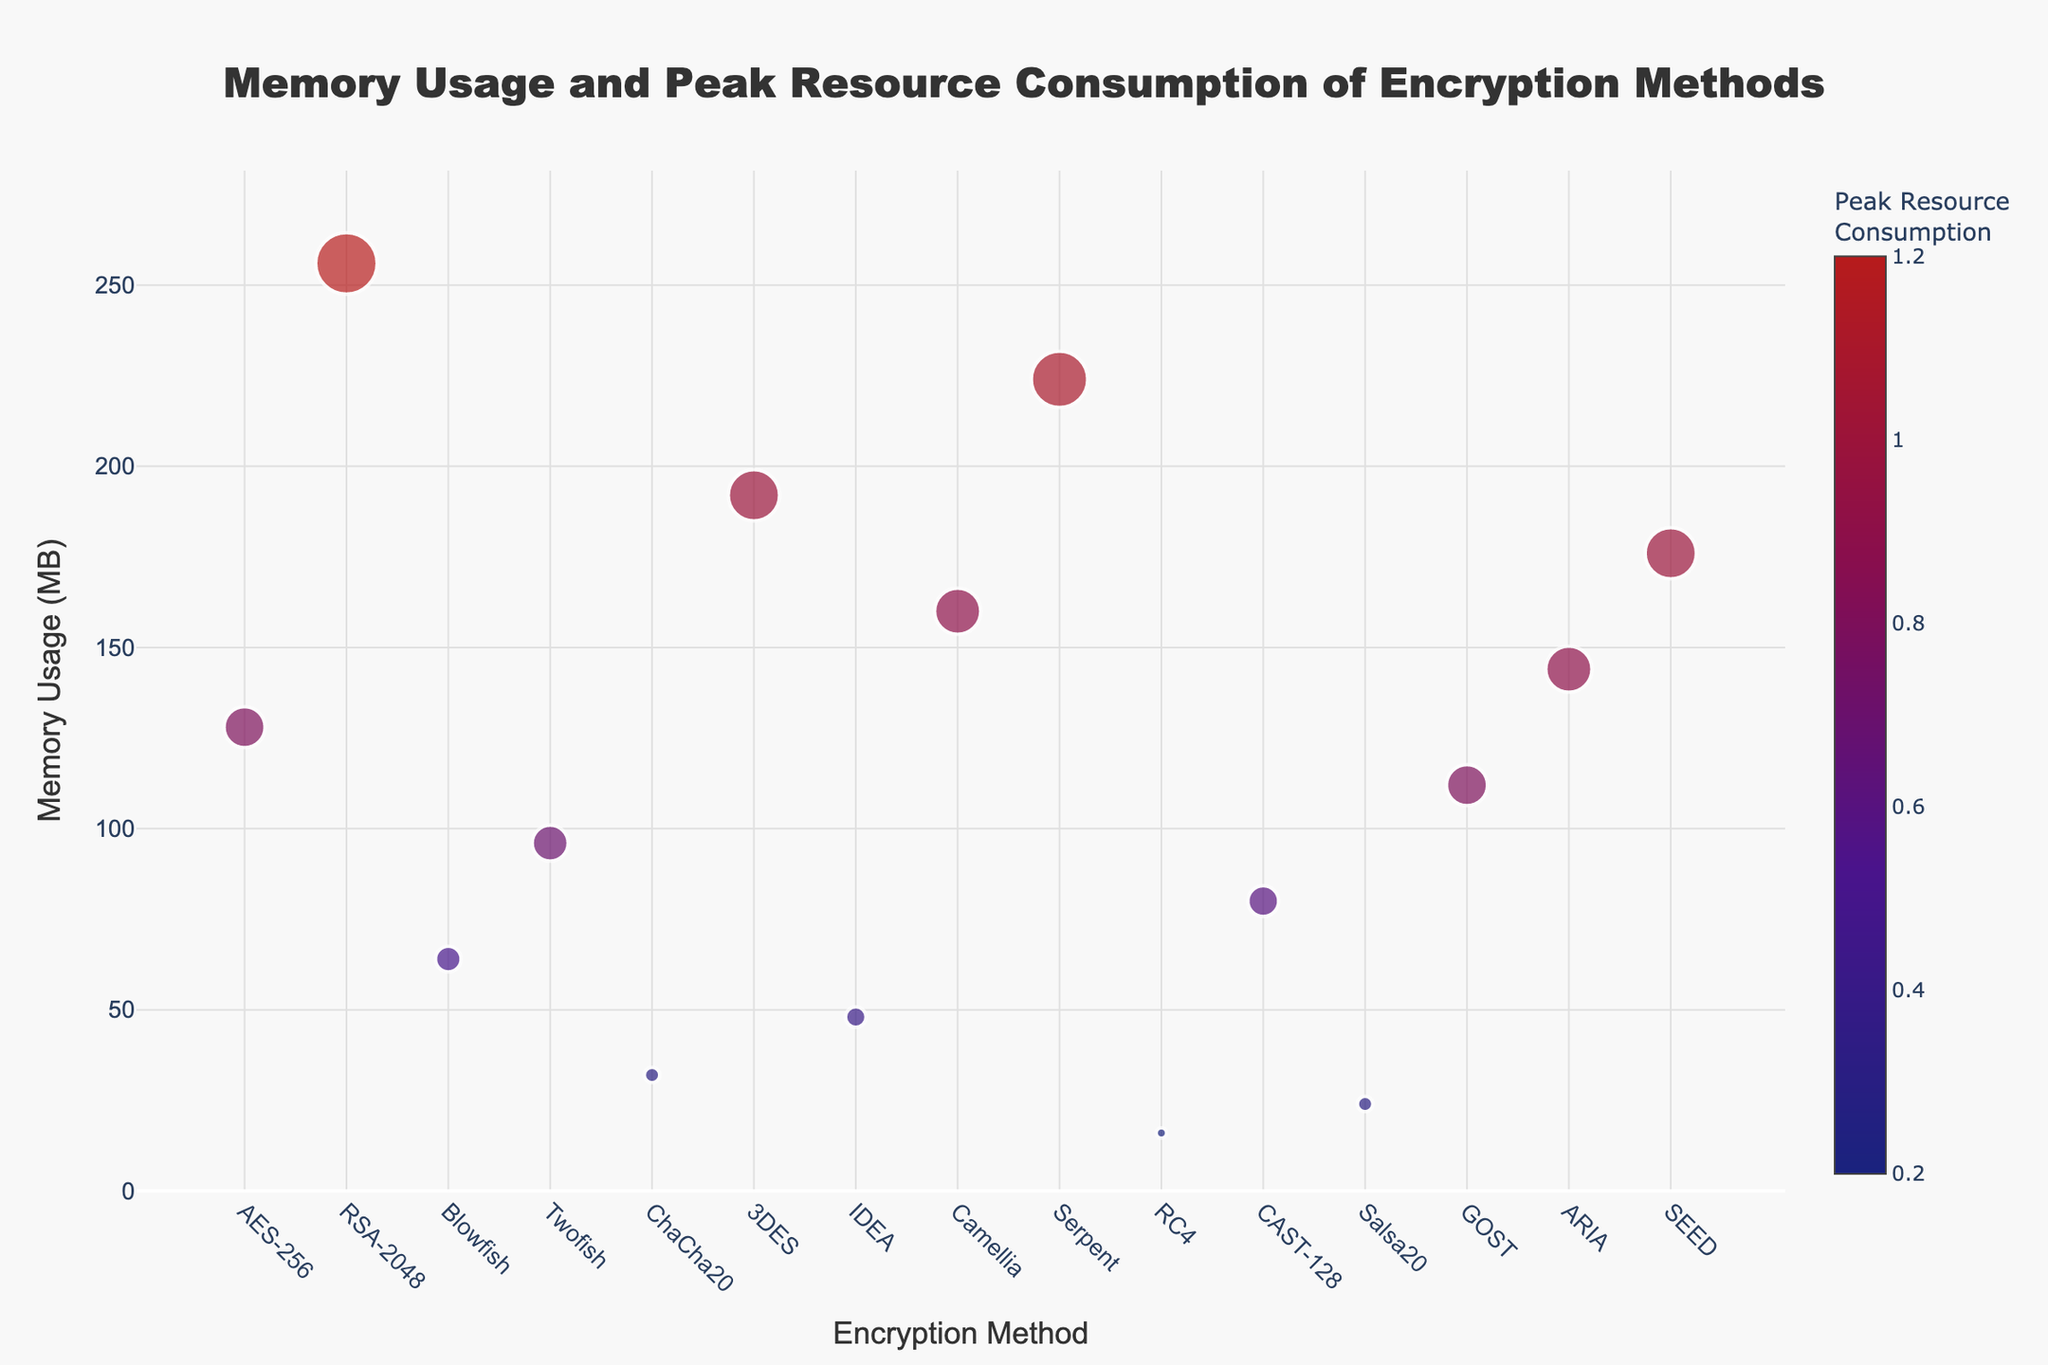How many encryption methods are displayed in the plot? Count the number of unique entries on the x-axis, each representing an encryption method.
Answer: 15 Which encryption method has the highest memory usage? Identify the data point with the highest y-value (memory usage) on the plot.
Answer: RSA-2048 What is the peak resource consumption for the encryption method with the lowest memory usage? Locate the lowest y-value (memory usage) data point and check its corresponding peak resource consumption.
Answer: 0.2 Which encryption method has the largest marker size? Identify the data point with the largest marker size, which corresponds to the highest peak resource consumption.
Answer: RSA-2048 Compare the memory usage between AES-256 and Twofish. Which one is higher? Look at the memory usage values (y-axis) for both AES-256 and Twofish and compare them.
Answer: AES-256 Which encryption methods have a peak resource consumption above 1.0? Identify the data points with peak resource consumption values greater than 1.0 on the color bar.
Answer: RSA-2048, Serpent, 3DES, SEED What is the average memory usage of all the encryption methods? Calculate the mean of all y-values (memory usage) by summing them up and dividing by the number of methods.
Answer: (128 + 256 + 64 + 96 + 32 + 192 + 48 + 160 + 224 + 16 + 80 + 24 + 112 + 144 + 176) / 15 = 123.733 MB Which encryption method shows relatively moderate memory usage and peak resource consumption? Look for data points that fall between high and low extremes on both axes and have moderate marker sizes and colors.
Answer: ChaCha20, IDEA Compare RSA-2048 and Serpent in terms of both memory usage and peak resource consumption. Which one is more demanding? Compare both y-values (memory usage) and marker sizes/colors (peak resource consumption) for RSA-2048 and Serpent. RSA-2048 has higher memory usage (256 vs 224 MB) but similar peak resource consumption (1.2 vs 1.1).
Answer: RSA-2048 What trend do you notice in the relationship between memory usage and peak resource consumption? Observe if there is a pattern in which higher memory usage often correlates with higher peak resource consumption values.
Answer: Higher memory usage tends to have higher peak resource consumption 